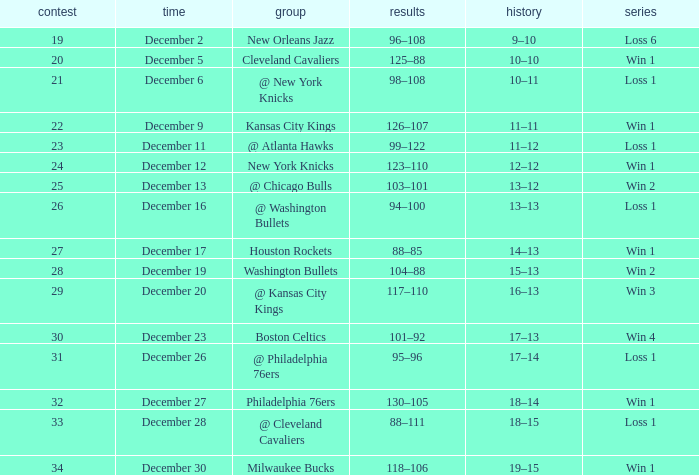What is the streak for december 30? Win 1. 